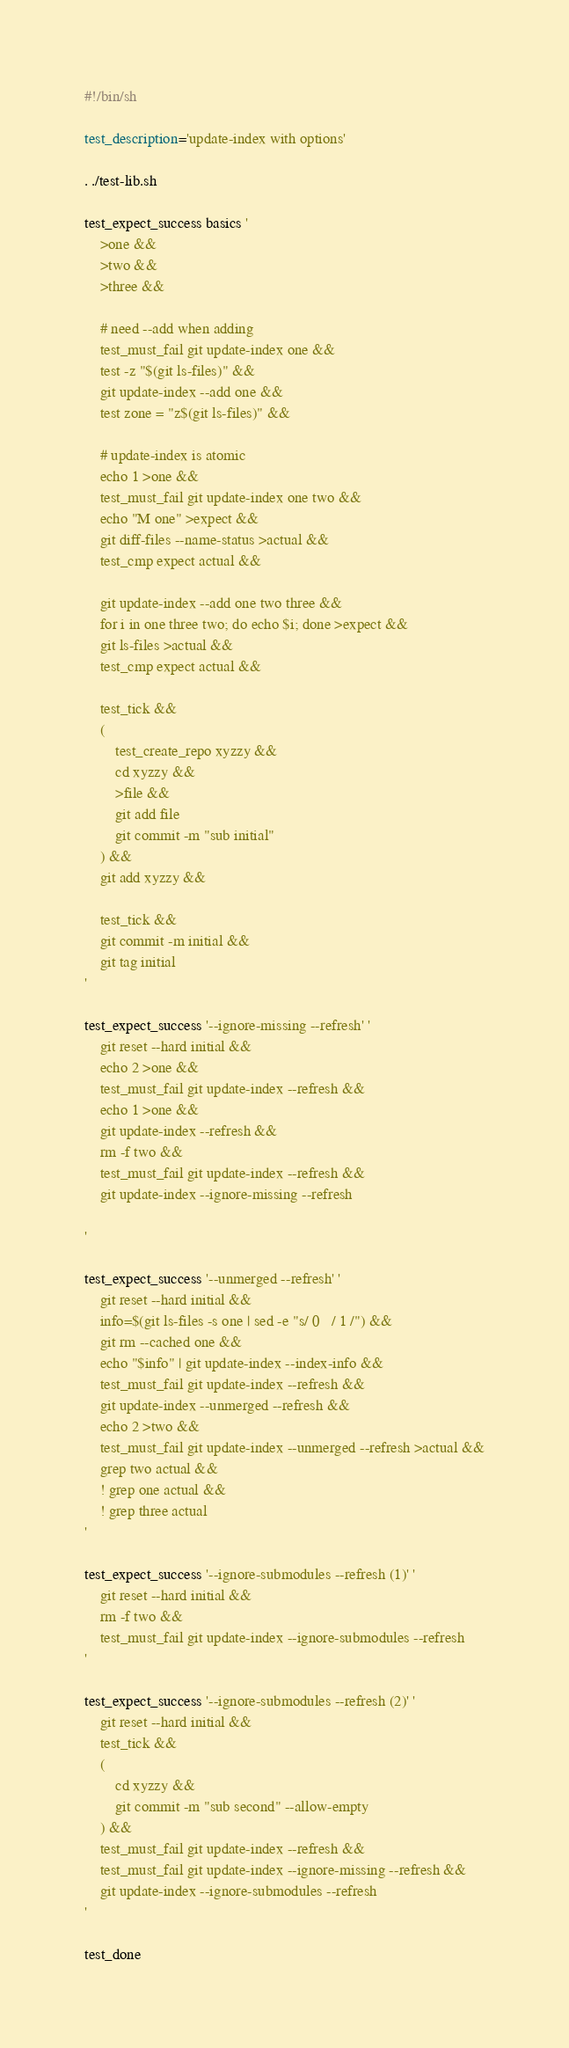Convert code to text. <code><loc_0><loc_0><loc_500><loc_500><_Bash_>#!/bin/sh

test_description='update-index with options'

. ./test-lib.sh

test_expect_success basics '
	>one &&
	>two &&
	>three &&

	# need --add when adding
	test_must_fail git update-index one &&
	test -z "$(git ls-files)" &&
	git update-index --add one &&
	test zone = "z$(git ls-files)" &&

	# update-index is atomic
	echo 1 >one &&
	test_must_fail git update-index one two &&
	echo "M	one" >expect &&
	git diff-files --name-status >actual &&
	test_cmp expect actual &&

	git update-index --add one two three &&
	for i in one three two; do echo $i; done >expect &&
	git ls-files >actual &&
	test_cmp expect actual &&

	test_tick &&
	(
		test_create_repo xyzzy &&
		cd xyzzy &&
		>file &&
		git add file
		git commit -m "sub initial"
	) &&
	git add xyzzy &&

	test_tick &&
	git commit -m initial &&
	git tag initial
'

test_expect_success '--ignore-missing --refresh' '
	git reset --hard initial &&
	echo 2 >one &&
	test_must_fail git update-index --refresh &&
	echo 1 >one &&
	git update-index --refresh &&
	rm -f two &&
	test_must_fail git update-index --refresh &&
	git update-index --ignore-missing --refresh

'

test_expect_success '--unmerged --refresh' '
	git reset --hard initial &&
	info=$(git ls-files -s one | sed -e "s/ 0	/ 1	/") &&
	git rm --cached one &&
	echo "$info" | git update-index --index-info &&
	test_must_fail git update-index --refresh &&
	git update-index --unmerged --refresh &&
	echo 2 >two &&
	test_must_fail git update-index --unmerged --refresh >actual &&
	grep two actual &&
	! grep one actual &&
	! grep three actual
'

test_expect_success '--ignore-submodules --refresh (1)' '
	git reset --hard initial &&
	rm -f two &&
	test_must_fail git update-index --ignore-submodules --refresh
'

test_expect_success '--ignore-submodules --refresh (2)' '
	git reset --hard initial &&
	test_tick &&
	(
		cd xyzzy &&
		git commit -m "sub second" --allow-empty
	) &&
	test_must_fail git update-index --refresh &&
	test_must_fail git update-index --ignore-missing --refresh &&
	git update-index --ignore-submodules --refresh
'

test_done
</code> 